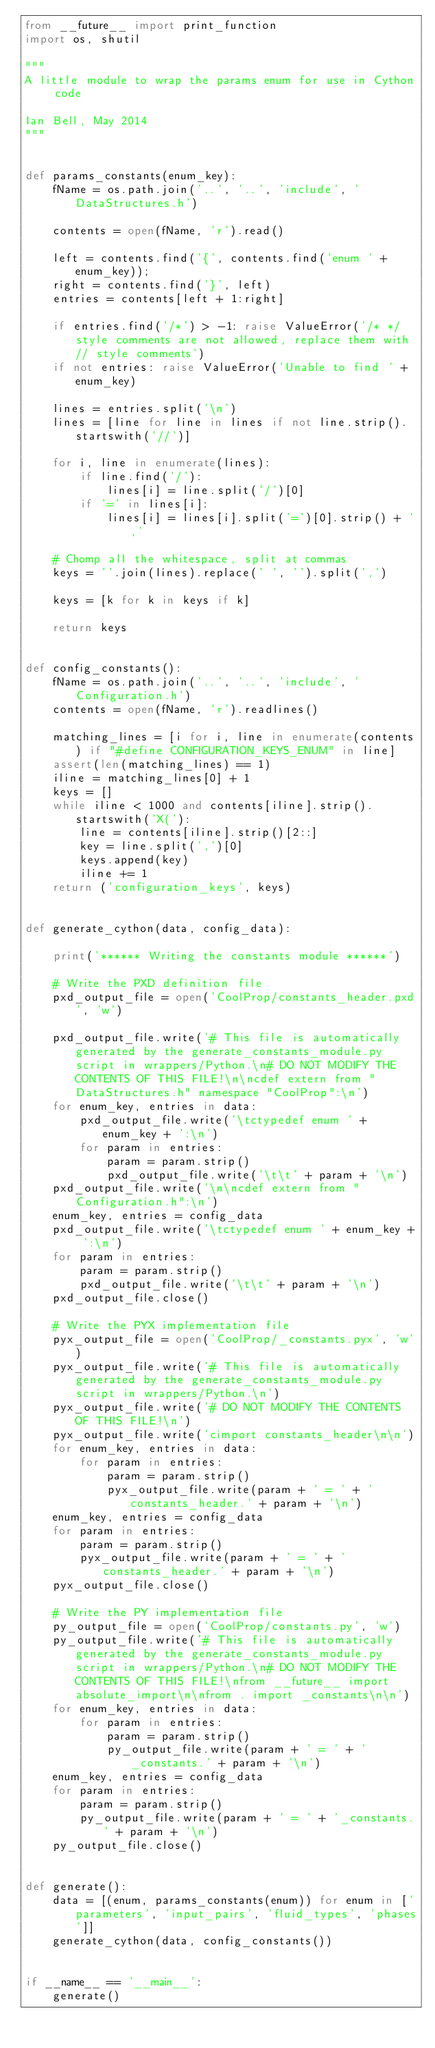Convert code to text. <code><loc_0><loc_0><loc_500><loc_500><_Python_>from __future__ import print_function
import os, shutil

"""
A little module to wrap the params enum for use in Cython code

Ian Bell, May 2014
"""


def params_constants(enum_key):
    fName = os.path.join('..', '..', 'include', 'DataStructures.h')

    contents = open(fName, 'r').read()

    left = contents.find('{', contents.find('enum ' + enum_key));
    right = contents.find('}', left)
    entries = contents[left + 1:right]

    if entries.find('/*') > -1: raise ValueError('/* */ style comments are not allowed, replace them with // style comments')
    if not entries: raise ValueError('Unable to find ' + enum_key)

    lines = entries.split('\n')
    lines = [line for line in lines if not line.strip().startswith('//')]

    for i, line in enumerate(lines):
        if line.find('/'):
            lines[i] = line.split('/')[0]
        if '=' in lines[i]:
            lines[i] = lines[i].split('=')[0].strip() + ','

    # Chomp all the whitespace, split at commas
    keys = ''.join(lines).replace(' ', '').split(',')

    keys = [k for k in keys if k]

    return keys


def config_constants():
    fName = os.path.join('..', '..', 'include', 'Configuration.h')
    contents = open(fName, 'r').readlines()

    matching_lines = [i for i, line in enumerate(contents) if "#define CONFIGURATION_KEYS_ENUM" in line]
    assert(len(matching_lines) == 1)
    iline = matching_lines[0] + 1
    keys = []
    while iline < 1000 and contents[iline].strip().startswith('X('):
        line = contents[iline].strip()[2::]
        key = line.split(',')[0]
        keys.append(key)
        iline += 1
    return ('configuration_keys', keys)


def generate_cython(data, config_data):

    print('****** Writing the constants module ******')

    # Write the PXD definition file
    pxd_output_file = open('CoolProp/constants_header.pxd', 'w')

    pxd_output_file.write('# This file is automatically generated by the generate_constants_module.py script in wrappers/Python.\n# DO NOT MODIFY THE CONTENTS OF THIS FILE!\n\ncdef extern from "DataStructures.h" namespace "CoolProp":\n')
    for enum_key, entries in data:
        pxd_output_file.write('\tctypedef enum ' + enum_key + ':\n')
        for param in entries:
            param = param.strip()
            pxd_output_file.write('\t\t' + param + '\n')
    pxd_output_file.write('\n\ncdef extern from "Configuration.h":\n')
    enum_key, entries = config_data
    pxd_output_file.write('\tctypedef enum ' + enum_key + ':\n')
    for param in entries:
        param = param.strip()
        pxd_output_file.write('\t\t' + param + '\n')
    pxd_output_file.close()

    # Write the PYX implementation file
    pyx_output_file = open('CoolProp/_constants.pyx', 'w')
    pyx_output_file.write('# This file is automatically generated by the generate_constants_module.py script in wrappers/Python.\n')
    pyx_output_file.write('# DO NOT MODIFY THE CONTENTS OF THIS FILE!\n')
    pyx_output_file.write('cimport constants_header\n\n')
    for enum_key, entries in data:
        for param in entries:
            param = param.strip()
            pyx_output_file.write(param + ' = ' + 'constants_header.' + param + '\n')
    enum_key, entries = config_data
    for param in entries:
        param = param.strip()
        pyx_output_file.write(param + ' = ' + 'constants_header.' + param + '\n')
    pyx_output_file.close()

    # Write the PY implementation file
    py_output_file = open('CoolProp/constants.py', 'w')
    py_output_file.write('# This file is automatically generated by the generate_constants_module.py script in wrappers/Python.\n# DO NOT MODIFY THE CONTENTS OF THIS FILE!\nfrom __future__ import absolute_import\n\nfrom . import _constants\n\n')
    for enum_key, entries in data:
        for param in entries:
            param = param.strip()
            py_output_file.write(param + ' = ' + '_constants.' + param + '\n')
    enum_key, entries = config_data
    for param in entries:
        param = param.strip()
        py_output_file.write(param + ' = ' + '_constants.' + param + '\n')
    py_output_file.close()


def generate():
    data = [(enum, params_constants(enum)) for enum in ['parameters', 'input_pairs', 'fluid_types', 'phases']]
    generate_cython(data, config_constants())


if __name__ == '__main__':
    generate()
</code> 